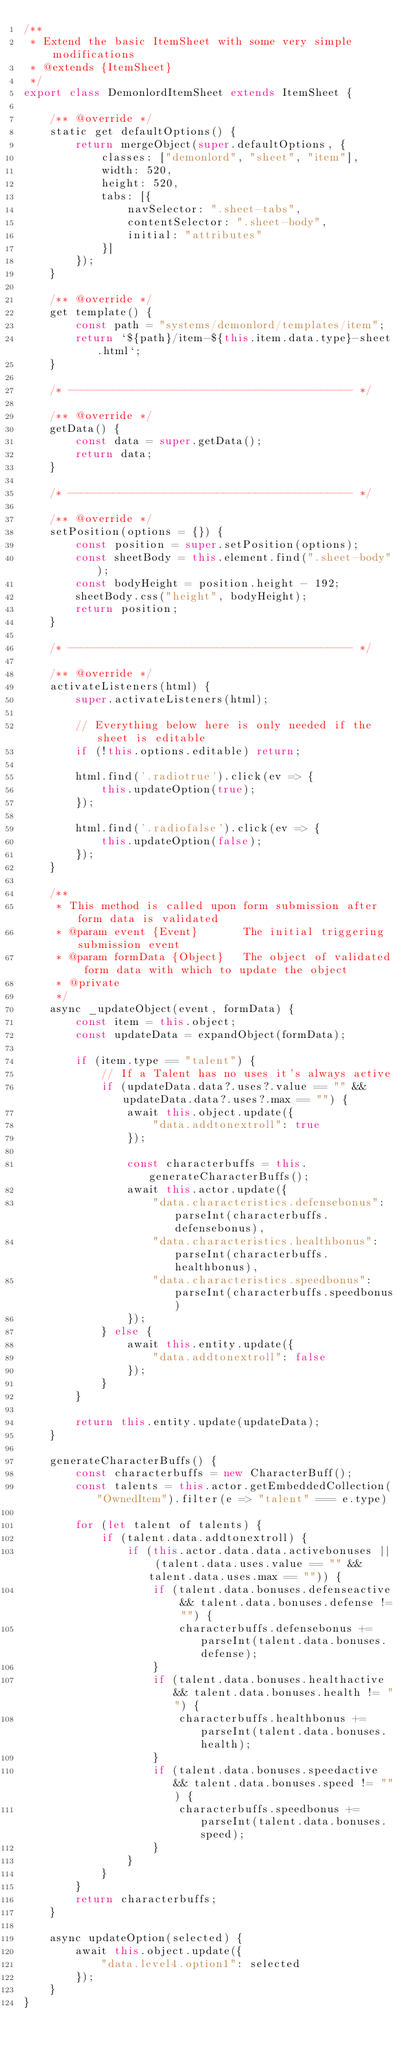Convert code to text. <code><loc_0><loc_0><loc_500><loc_500><_JavaScript_>/**
 * Extend the basic ItemSheet with some very simple modifications
 * @extends {ItemSheet}
 */
export class DemonlordItemSheet extends ItemSheet {

    /** @override */
    static get defaultOptions() {
        return mergeObject(super.defaultOptions, {
            classes: ["demonlord", "sheet", "item"],
            width: 520,
            height: 520,
            tabs: [{
                navSelector: ".sheet-tabs",
                contentSelector: ".sheet-body",
                initial: "attributes"
            }]
        });
    }

    /** @override */
    get template() {
        const path = "systems/demonlord/templates/item";
        return `${path}/item-${this.item.data.type}-sheet.html`;
    }

    /* -------------------------------------------- */

    /** @override */
    getData() {
        const data = super.getData();
        return data;
    }

    /* -------------------------------------------- */

    /** @override */
    setPosition(options = {}) {
        const position = super.setPosition(options);
        const sheetBody = this.element.find(".sheet-body");
        const bodyHeight = position.height - 192;
        sheetBody.css("height", bodyHeight);
        return position;
    }

    /* -------------------------------------------- */

    /** @override */
    activateListeners(html) {
        super.activateListeners(html);

        // Everything below here is only needed if the sheet is editable
        if (!this.options.editable) return;

        html.find('.radiotrue').click(ev => {
            this.updateOption(true);
        });

        html.find('.radiofalse').click(ev => {
            this.updateOption(false);
        });
    }

    /**
     * This method is called upon form submission after form data is validated
     * @param event {Event}       The initial triggering submission event
     * @param formData {Object}   The object of validated form data with which to update the object
     * @private
     */
    async _updateObject(event, formData) {
        const item = this.object;
        const updateData = expandObject(formData);

        if (item.type == "talent") {
            // If a Talent has no uses it's always active
            if (updateData.data?.uses?.value == "" && updateData.data?.uses?.max == "") {
                await this.object.update({
                    "data.addtonextroll": true
                });

                const characterbuffs = this.generateCharacterBuffs();
                await this.actor.update({
                    "data.characteristics.defensebonus": parseInt(characterbuffs.defensebonus),
                    "data.characteristics.healthbonus": parseInt(characterbuffs.healthbonus),
                    "data.characteristics.speedbonus": parseInt(characterbuffs.speedbonus)
                });
            } else {
                await this.entity.update({
                    "data.addtonextroll": false
                });
            }
        }

        return this.entity.update(updateData);
    }

    generateCharacterBuffs() {
        const characterbuffs = new CharacterBuff();
        const talents = this.actor.getEmbeddedCollection("OwnedItem").filter(e => "talent" === e.type)

        for (let talent of talents) {
            if (talent.data.addtonextroll) {
                if (this.actor.data.data.activebonuses || (talent.data.uses.value == "" && talent.data.uses.max == "")) {
                    if (talent.data.bonuses.defenseactive && talent.data.bonuses.defense != "") {
                        characterbuffs.defensebonus += parseInt(talent.data.bonuses.defense);
                    }
                    if (talent.data.bonuses.healthactive && talent.data.bonuses.health != "") {
                        characterbuffs.healthbonus += parseInt(talent.data.bonuses.health);
                    }
                    if (talent.data.bonuses.speedactive && talent.data.bonuses.speed != "") {
                        characterbuffs.speedbonus += parseInt(talent.data.bonuses.speed);
                    }
                }
            }
        }
        return characterbuffs;
    }

    async updateOption(selected) {
        await this.object.update({
            "data.level4.option1": selected
        });
    }
}
</code> 